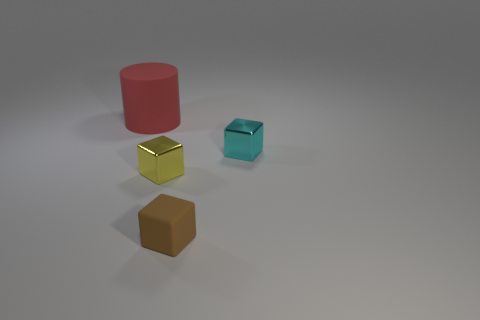Is there any other thing that is the same size as the cylinder?
Keep it short and to the point. No. What material is the block that is behind the block that is to the left of the matte thing right of the large red cylinder?
Keep it short and to the point. Metal. What number of cyan metallic objects are the same size as the yellow cube?
Make the answer very short. 1. There is a tiny cube that is behind the small brown rubber thing and to the left of the tiny cyan cube; what material is it made of?
Offer a very short reply. Metal. How many small yellow metal blocks are to the right of the large red object?
Give a very brief answer. 1. Do the small yellow metal object and the brown object that is in front of the tiny cyan block have the same shape?
Your answer should be very brief. Yes. Is there a tiny yellow object of the same shape as the small brown matte object?
Offer a very short reply. Yes. There is a metallic object to the right of the matte thing that is in front of the large thing; what shape is it?
Give a very brief answer. Cube. What shape is the rubber thing that is right of the yellow metal thing?
Give a very brief answer. Cube. What number of things are both on the left side of the tiny rubber object and in front of the large thing?
Keep it short and to the point. 1. 